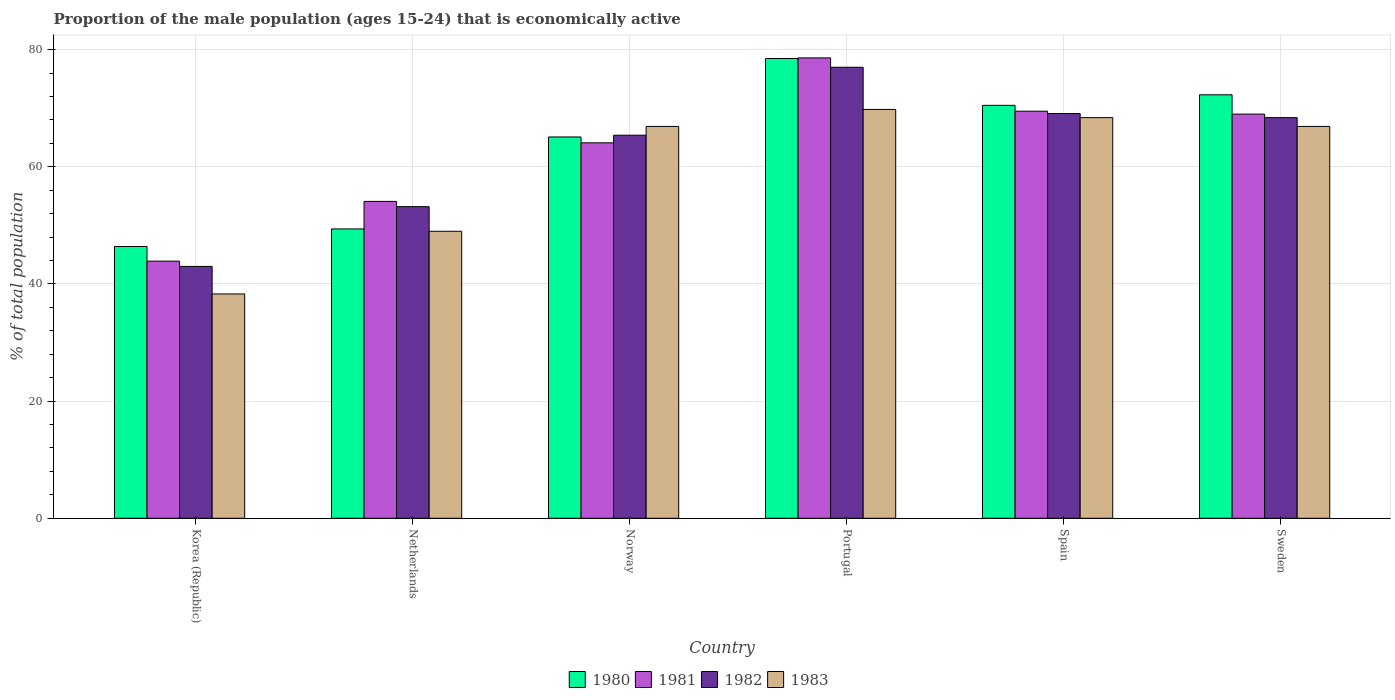How many groups of bars are there?
Provide a succinct answer. 6. Are the number of bars per tick equal to the number of legend labels?
Your response must be concise. Yes. In how many cases, is the number of bars for a given country not equal to the number of legend labels?
Give a very brief answer. 0. What is the proportion of the male population that is economically active in 1981 in Norway?
Your response must be concise. 64.1. Across all countries, what is the maximum proportion of the male population that is economically active in 1981?
Offer a terse response. 78.6. In which country was the proportion of the male population that is economically active in 1981 maximum?
Provide a short and direct response. Portugal. What is the total proportion of the male population that is economically active in 1982 in the graph?
Your answer should be very brief. 376.1. What is the difference between the proportion of the male population that is economically active in 1981 in Netherlands and that in Spain?
Offer a terse response. -15.4. What is the difference between the proportion of the male population that is economically active in 1980 in Sweden and the proportion of the male population that is economically active in 1982 in Spain?
Your answer should be compact. 3.2. What is the average proportion of the male population that is economically active in 1980 per country?
Your answer should be compact. 63.7. What is the difference between the proportion of the male population that is economically active of/in 1982 and proportion of the male population that is economically active of/in 1981 in Netherlands?
Keep it short and to the point. -0.9. In how many countries, is the proportion of the male population that is economically active in 1980 greater than 28 %?
Offer a very short reply. 6. What is the ratio of the proportion of the male population that is economically active in 1981 in Portugal to that in Sweden?
Offer a very short reply. 1.14. Is the proportion of the male population that is economically active in 1982 in Netherlands less than that in Spain?
Offer a terse response. Yes. What is the difference between the highest and the second highest proportion of the male population that is economically active in 1980?
Provide a succinct answer. 1.8. What is the difference between the highest and the lowest proportion of the male population that is economically active in 1980?
Ensure brevity in your answer.  32.1. In how many countries, is the proportion of the male population that is economically active in 1983 greater than the average proportion of the male population that is economically active in 1983 taken over all countries?
Your answer should be compact. 4. Is it the case that in every country, the sum of the proportion of the male population that is economically active in 1981 and proportion of the male population that is economically active in 1983 is greater than the sum of proportion of the male population that is economically active in 1980 and proportion of the male population that is economically active in 1982?
Your answer should be very brief. No. What does the 4th bar from the left in Norway represents?
Your answer should be compact. 1983. Is it the case that in every country, the sum of the proportion of the male population that is economically active in 1981 and proportion of the male population that is economically active in 1983 is greater than the proportion of the male population that is economically active in 1980?
Make the answer very short. Yes. Are all the bars in the graph horizontal?
Provide a short and direct response. No. What is the difference between two consecutive major ticks on the Y-axis?
Your answer should be compact. 20. Does the graph contain grids?
Your answer should be very brief. Yes. Where does the legend appear in the graph?
Your answer should be compact. Bottom center. How many legend labels are there?
Offer a terse response. 4. How are the legend labels stacked?
Make the answer very short. Horizontal. What is the title of the graph?
Ensure brevity in your answer.  Proportion of the male population (ages 15-24) that is economically active. What is the label or title of the X-axis?
Keep it short and to the point. Country. What is the label or title of the Y-axis?
Your answer should be very brief. % of total population. What is the % of total population of 1980 in Korea (Republic)?
Provide a succinct answer. 46.4. What is the % of total population of 1981 in Korea (Republic)?
Offer a terse response. 43.9. What is the % of total population in 1983 in Korea (Republic)?
Your answer should be compact. 38.3. What is the % of total population in 1980 in Netherlands?
Your response must be concise. 49.4. What is the % of total population of 1981 in Netherlands?
Provide a short and direct response. 54.1. What is the % of total population of 1982 in Netherlands?
Offer a terse response. 53.2. What is the % of total population in 1980 in Norway?
Your response must be concise. 65.1. What is the % of total population of 1981 in Norway?
Provide a short and direct response. 64.1. What is the % of total population in 1982 in Norway?
Offer a terse response. 65.4. What is the % of total population of 1983 in Norway?
Your answer should be compact. 66.9. What is the % of total population of 1980 in Portugal?
Provide a succinct answer. 78.5. What is the % of total population of 1981 in Portugal?
Provide a short and direct response. 78.6. What is the % of total population of 1982 in Portugal?
Ensure brevity in your answer.  77. What is the % of total population of 1983 in Portugal?
Provide a short and direct response. 69.8. What is the % of total population in 1980 in Spain?
Provide a succinct answer. 70.5. What is the % of total population in 1981 in Spain?
Ensure brevity in your answer.  69.5. What is the % of total population of 1982 in Spain?
Offer a terse response. 69.1. What is the % of total population of 1983 in Spain?
Give a very brief answer. 68.4. What is the % of total population of 1980 in Sweden?
Offer a very short reply. 72.3. What is the % of total population of 1981 in Sweden?
Offer a very short reply. 69. What is the % of total population of 1982 in Sweden?
Give a very brief answer. 68.4. What is the % of total population of 1983 in Sweden?
Your response must be concise. 66.9. Across all countries, what is the maximum % of total population in 1980?
Offer a terse response. 78.5. Across all countries, what is the maximum % of total population in 1981?
Provide a succinct answer. 78.6. Across all countries, what is the maximum % of total population of 1982?
Your answer should be very brief. 77. Across all countries, what is the maximum % of total population in 1983?
Make the answer very short. 69.8. Across all countries, what is the minimum % of total population of 1980?
Provide a succinct answer. 46.4. Across all countries, what is the minimum % of total population of 1981?
Your answer should be very brief. 43.9. Across all countries, what is the minimum % of total population in 1983?
Your answer should be very brief. 38.3. What is the total % of total population of 1980 in the graph?
Provide a succinct answer. 382.2. What is the total % of total population in 1981 in the graph?
Give a very brief answer. 379.2. What is the total % of total population in 1982 in the graph?
Ensure brevity in your answer.  376.1. What is the total % of total population in 1983 in the graph?
Offer a terse response. 359.3. What is the difference between the % of total population of 1981 in Korea (Republic) and that in Netherlands?
Provide a succinct answer. -10.2. What is the difference between the % of total population of 1982 in Korea (Republic) and that in Netherlands?
Keep it short and to the point. -10.2. What is the difference between the % of total population of 1983 in Korea (Republic) and that in Netherlands?
Keep it short and to the point. -10.7. What is the difference between the % of total population in 1980 in Korea (Republic) and that in Norway?
Offer a terse response. -18.7. What is the difference between the % of total population in 1981 in Korea (Republic) and that in Norway?
Give a very brief answer. -20.2. What is the difference between the % of total population of 1982 in Korea (Republic) and that in Norway?
Offer a terse response. -22.4. What is the difference between the % of total population of 1983 in Korea (Republic) and that in Norway?
Your answer should be very brief. -28.6. What is the difference between the % of total population in 1980 in Korea (Republic) and that in Portugal?
Your response must be concise. -32.1. What is the difference between the % of total population in 1981 in Korea (Republic) and that in Portugal?
Offer a very short reply. -34.7. What is the difference between the % of total population in 1982 in Korea (Republic) and that in Portugal?
Provide a succinct answer. -34. What is the difference between the % of total population in 1983 in Korea (Republic) and that in Portugal?
Offer a very short reply. -31.5. What is the difference between the % of total population of 1980 in Korea (Republic) and that in Spain?
Provide a short and direct response. -24.1. What is the difference between the % of total population in 1981 in Korea (Republic) and that in Spain?
Offer a terse response. -25.6. What is the difference between the % of total population in 1982 in Korea (Republic) and that in Spain?
Provide a succinct answer. -26.1. What is the difference between the % of total population in 1983 in Korea (Republic) and that in Spain?
Make the answer very short. -30.1. What is the difference between the % of total population of 1980 in Korea (Republic) and that in Sweden?
Provide a succinct answer. -25.9. What is the difference between the % of total population of 1981 in Korea (Republic) and that in Sweden?
Your answer should be very brief. -25.1. What is the difference between the % of total population in 1982 in Korea (Republic) and that in Sweden?
Offer a terse response. -25.4. What is the difference between the % of total population in 1983 in Korea (Republic) and that in Sweden?
Your response must be concise. -28.6. What is the difference between the % of total population in 1980 in Netherlands and that in Norway?
Give a very brief answer. -15.7. What is the difference between the % of total population of 1981 in Netherlands and that in Norway?
Your response must be concise. -10. What is the difference between the % of total population in 1983 in Netherlands and that in Norway?
Ensure brevity in your answer.  -17.9. What is the difference between the % of total population in 1980 in Netherlands and that in Portugal?
Ensure brevity in your answer.  -29.1. What is the difference between the % of total population of 1981 in Netherlands and that in Portugal?
Keep it short and to the point. -24.5. What is the difference between the % of total population of 1982 in Netherlands and that in Portugal?
Make the answer very short. -23.8. What is the difference between the % of total population in 1983 in Netherlands and that in Portugal?
Offer a terse response. -20.8. What is the difference between the % of total population of 1980 in Netherlands and that in Spain?
Provide a succinct answer. -21.1. What is the difference between the % of total population of 1981 in Netherlands and that in Spain?
Give a very brief answer. -15.4. What is the difference between the % of total population in 1982 in Netherlands and that in Spain?
Your answer should be compact. -15.9. What is the difference between the % of total population in 1983 in Netherlands and that in Spain?
Give a very brief answer. -19.4. What is the difference between the % of total population in 1980 in Netherlands and that in Sweden?
Give a very brief answer. -22.9. What is the difference between the % of total population in 1981 in Netherlands and that in Sweden?
Offer a terse response. -14.9. What is the difference between the % of total population of 1982 in Netherlands and that in Sweden?
Your answer should be very brief. -15.2. What is the difference between the % of total population in 1983 in Netherlands and that in Sweden?
Your answer should be compact. -17.9. What is the difference between the % of total population in 1980 in Norway and that in Portugal?
Give a very brief answer. -13.4. What is the difference between the % of total population in 1980 in Norway and that in Spain?
Your answer should be very brief. -5.4. What is the difference between the % of total population in 1981 in Norway and that in Spain?
Keep it short and to the point. -5.4. What is the difference between the % of total population of 1983 in Norway and that in Spain?
Offer a very short reply. -1.5. What is the difference between the % of total population in 1982 in Norway and that in Sweden?
Offer a terse response. -3. What is the difference between the % of total population of 1983 in Norway and that in Sweden?
Make the answer very short. 0. What is the difference between the % of total population of 1982 in Portugal and that in Spain?
Give a very brief answer. 7.9. What is the difference between the % of total population of 1980 in Portugal and that in Sweden?
Your response must be concise. 6.2. What is the difference between the % of total population in 1981 in Spain and that in Sweden?
Keep it short and to the point. 0.5. What is the difference between the % of total population in 1982 in Spain and that in Sweden?
Your answer should be very brief. 0.7. What is the difference between the % of total population in 1983 in Spain and that in Sweden?
Provide a short and direct response. 1.5. What is the difference between the % of total population in 1980 in Korea (Republic) and the % of total population in 1981 in Netherlands?
Offer a very short reply. -7.7. What is the difference between the % of total population in 1980 in Korea (Republic) and the % of total population in 1982 in Netherlands?
Your answer should be compact. -6.8. What is the difference between the % of total population of 1980 in Korea (Republic) and the % of total population of 1983 in Netherlands?
Make the answer very short. -2.6. What is the difference between the % of total population of 1982 in Korea (Republic) and the % of total population of 1983 in Netherlands?
Provide a short and direct response. -6. What is the difference between the % of total population in 1980 in Korea (Republic) and the % of total population in 1981 in Norway?
Provide a succinct answer. -17.7. What is the difference between the % of total population of 1980 in Korea (Republic) and the % of total population of 1982 in Norway?
Provide a short and direct response. -19. What is the difference between the % of total population of 1980 in Korea (Republic) and the % of total population of 1983 in Norway?
Offer a very short reply. -20.5. What is the difference between the % of total population of 1981 in Korea (Republic) and the % of total population of 1982 in Norway?
Your response must be concise. -21.5. What is the difference between the % of total population of 1981 in Korea (Republic) and the % of total population of 1983 in Norway?
Keep it short and to the point. -23. What is the difference between the % of total population in 1982 in Korea (Republic) and the % of total population in 1983 in Norway?
Provide a short and direct response. -23.9. What is the difference between the % of total population in 1980 in Korea (Republic) and the % of total population in 1981 in Portugal?
Your response must be concise. -32.2. What is the difference between the % of total population in 1980 in Korea (Republic) and the % of total population in 1982 in Portugal?
Give a very brief answer. -30.6. What is the difference between the % of total population in 1980 in Korea (Republic) and the % of total population in 1983 in Portugal?
Make the answer very short. -23.4. What is the difference between the % of total population in 1981 in Korea (Republic) and the % of total population in 1982 in Portugal?
Make the answer very short. -33.1. What is the difference between the % of total population in 1981 in Korea (Republic) and the % of total population in 1983 in Portugal?
Give a very brief answer. -25.9. What is the difference between the % of total population of 1982 in Korea (Republic) and the % of total population of 1983 in Portugal?
Give a very brief answer. -26.8. What is the difference between the % of total population in 1980 in Korea (Republic) and the % of total population in 1981 in Spain?
Offer a terse response. -23.1. What is the difference between the % of total population in 1980 in Korea (Republic) and the % of total population in 1982 in Spain?
Your answer should be very brief. -22.7. What is the difference between the % of total population of 1981 in Korea (Republic) and the % of total population of 1982 in Spain?
Your response must be concise. -25.2. What is the difference between the % of total population in 1981 in Korea (Republic) and the % of total population in 1983 in Spain?
Ensure brevity in your answer.  -24.5. What is the difference between the % of total population in 1982 in Korea (Republic) and the % of total population in 1983 in Spain?
Your response must be concise. -25.4. What is the difference between the % of total population of 1980 in Korea (Republic) and the % of total population of 1981 in Sweden?
Offer a terse response. -22.6. What is the difference between the % of total population of 1980 in Korea (Republic) and the % of total population of 1983 in Sweden?
Keep it short and to the point. -20.5. What is the difference between the % of total population in 1981 in Korea (Republic) and the % of total population in 1982 in Sweden?
Keep it short and to the point. -24.5. What is the difference between the % of total population in 1982 in Korea (Republic) and the % of total population in 1983 in Sweden?
Keep it short and to the point. -23.9. What is the difference between the % of total population in 1980 in Netherlands and the % of total population in 1981 in Norway?
Your answer should be compact. -14.7. What is the difference between the % of total population in 1980 in Netherlands and the % of total population in 1982 in Norway?
Your answer should be very brief. -16. What is the difference between the % of total population of 1980 in Netherlands and the % of total population of 1983 in Norway?
Your answer should be compact. -17.5. What is the difference between the % of total population in 1981 in Netherlands and the % of total population in 1982 in Norway?
Ensure brevity in your answer.  -11.3. What is the difference between the % of total population in 1982 in Netherlands and the % of total population in 1983 in Norway?
Your answer should be very brief. -13.7. What is the difference between the % of total population of 1980 in Netherlands and the % of total population of 1981 in Portugal?
Your response must be concise. -29.2. What is the difference between the % of total population in 1980 in Netherlands and the % of total population in 1982 in Portugal?
Provide a succinct answer. -27.6. What is the difference between the % of total population in 1980 in Netherlands and the % of total population in 1983 in Portugal?
Keep it short and to the point. -20.4. What is the difference between the % of total population in 1981 in Netherlands and the % of total population in 1982 in Portugal?
Keep it short and to the point. -22.9. What is the difference between the % of total population of 1981 in Netherlands and the % of total population of 1983 in Portugal?
Ensure brevity in your answer.  -15.7. What is the difference between the % of total population of 1982 in Netherlands and the % of total population of 1983 in Portugal?
Provide a succinct answer. -16.6. What is the difference between the % of total population of 1980 in Netherlands and the % of total population of 1981 in Spain?
Keep it short and to the point. -20.1. What is the difference between the % of total population of 1980 in Netherlands and the % of total population of 1982 in Spain?
Offer a terse response. -19.7. What is the difference between the % of total population of 1980 in Netherlands and the % of total population of 1983 in Spain?
Keep it short and to the point. -19. What is the difference between the % of total population in 1981 in Netherlands and the % of total population in 1982 in Spain?
Your answer should be compact. -15. What is the difference between the % of total population of 1981 in Netherlands and the % of total population of 1983 in Spain?
Offer a terse response. -14.3. What is the difference between the % of total population in 1982 in Netherlands and the % of total population in 1983 in Spain?
Offer a very short reply. -15.2. What is the difference between the % of total population in 1980 in Netherlands and the % of total population in 1981 in Sweden?
Give a very brief answer. -19.6. What is the difference between the % of total population in 1980 in Netherlands and the % of total population in 1982 in Sweden?
Ensure brevity in your answer.  -19. What is the difference between the % of total population of 1980 in Netherlands and the % of total population of 1983 in Sweden?
Provide a short and direct response. -17.5. What is the difference between the % of total population of 1981 in Netherlands and the % of total population of 1982 in Sweden?
Make the answer very short. -14.3. What is the difference between the % of total population of 1982 in Netherlands and the % of total population of 1983 in Sweden?
Your answer should be very brief. -13.7. What is the difference between the % of total population in 1981 in Norway and the % of total population in 1983 in Portugal?
Ensure brevity in your answer.  -5.7. What is the difference between the % of total population of 1980 in Norway and the % of total population of 1982 in Spain?
Your answer should be very brief. -4. What is the difference between the % of total population in 1981 in Norway and the % of total population in 1982 in Spain?
Ensure brevity in your answer.  -5. What is the difference between the % of total population in 1981 in Norway and the % of total population in 1983 in Spain?
Provide a succinct answer. -4.3. What is the difference between the % of total population in 1980 in Norway and the % of total population in 1982 in Sweden?
Your answer should be compact. -3.3. What is the difference between the % of total population of 1981 in Norway and the % of total population of 1982 in Sweden?
Your answer should be compact. -4.3. What is the difference between the % of total population of 1980 in Portugal and the % of total population of 1981 in Spain?
Keep it short and to the point. 9. What is the difference between the % of total population in 1980 in Portugal and the % of total population in 1983 in Spain?
Keep it short and to the point. 10.1. What is the difference between the % of total population in 1981 in Portugal and the % of total population in 1983 in Spain?
Offer a terse response. 10.2. What is the difference between the % of total population of 1980 in Portugal and the % of total population of 1981 in Sweden?
Make the answer very short. 9.5. What is the difference between the % of total population in 1980 in Portugal and the % of total population in 1982 in Sweden?
Ensure brevity in your answer.  10.1. What is the difference between the % of total population of 1981 in Portugal and the % of total population of 1983 in Sweden?
Provide a succinct answer. 11.7. What is the difference between the % of total population of 1981 in Spain and the % of total population of 1983 in Sweden?
Your answer should be compact. 2.6. What is the difference between the % of total population in 1982 in Spain and the % of total population in 1983 in Sweden?
Your answer should be compact. 2.2. What is the average % of total population of 1980 per country?
Your answer should be compact. 63.7. What is the average % of total population in 1981 per country?
Make the answer very short. 63.2. What is the average % of total population of 1982 per country?
Ensure brevity in your answer.  62.68. What is the average % of total population in 1983 per country?
Make the answer very short. 59.88. What is the difference between the % of total population of 1980 and % of total population of 1981 in Korea (Republic)?
Give a very brief answer. 2.5. What is the difference between the % of total population in 1980 and % of total population in 1982 in Korea (Republic)?
Your answer should be compact. 3.4. What is the difference between the % of total population of 1981 and % of total population of 1983 in Korea (Republic)?
Keep it short and to the point. 5.6. What is the difference between the % of total population of 1982 and % of total population of 1983 in Korea (Republic)?
Your response must be concise. 4.7. What is the difference between the % of total population in 1980 and % of total population in 1981 in Netherlands?
Keep it short and to the point. -4.7. What is the difference between the % of total population in 1980 and % of total population in 1983 in Netherlands?
Make the answer very short. 0.4. What is the difference between the % of total population in 1981 and % of total population in 1983 in Netherlands?
Keep it short and to the point. 5.1. What is the difference between the % of total population in 1982 and % of total population in 1983 in Netherlands?
Provide a short and direct response. 4.2. What is the difference between the % of total population of 1980 and % of total population of 1983 in Norway?
Ensure brevity in your answer.  -1.8. What is the difference between the % of total population of 1981 and % of total population of 1982 in Norway?
Ensure brevity in your answer.  -1.3. What is the difference between the % of total population of 1981 and % of total population of 1983 in Norway?
Your answer should be compact. -2.8. What is the difference between the % of total population of 1982 and % of total population of 1983 in Norway?
Provide a succinct answer. -1.5. What is the difference between the % of total population in 1980 and % of total population in 1981 in Portugal?
Ensure brevity in your answer.  -0.1. What is the difference between the % of total population in 1981 and % of total population in 1982 in Portugal?
Provide a succinct answer. 1.6. What is the difference between the % of total population in 1981 and % of total population in 1983 in Portugal?
Provide a short and direct response. 8.8. What is the difference between the % of total population of 1982 and % of total population of 1983 in Portugal?
Your response must be concise. 7.2. What is the difference between the % of total population of 1980 and % of total population of 1983 in Spain?
Provide a succinct answer. 2.1. What is the difference between the % of total population in 1982 and % of total population in 1983 in Spain?
Your response must be concise. 0.7. What is the difference between the % of total population in 1980 and % of total population in 1981 in Sweden?
Provide a succinct answer. 3.3. What is the difference between the % of total population in 1980 and % of total population in 1982 in Sweden?
Offer a terse response. 3.9. What is the difference between the % of total population in 1982 and % of total population in 1983 in Sweden?
Your answer should be compact. 1.5. What is the ratio of the % of total population of 1980 in Korea (Republic) to that in Netherlands?
Give a very brief answer. 0.94. What is the ratio of the % of total population in 1981 in Korea (Republic) to that in Netherlands?
Give a very brief answer. 0.81. What is the ratio of the % of total population in 1982 in Korea (Republic) to that in Netherlands?
Make the answer very short. 0.81. What is the ratio of the % of total population in 1983 in Korea (Republic) to that in Netherlands?
Provide a short and direct response. 0.78. What is the ratio of the % of total population in 1980 in Korea (Republic) to that in Norway?
Provide a succinct answer. 0.71. What is the ratio of the % of total population in 1981 in Korea (Republic) to that in Norway?
Make the answer very short. 0.68. What is the ratio of the % of total population of 1982 in Korea (Republic) to that in Norway?
Provide a short and direct response. 0.66. What is the ratio of the % of total population in 1983 in Korea (Republic) to that in Norway?
Ensure brevity in your answer.  0.57. What is the ratio of the % of total population in 1980 in Korea (Republic) to that in Portugal?
Your answer should be compact. 0.59. What is the ratio of the % of total population of 1981 in Korea (Republic) to that in Portugal?
Your answer should be very brief. 0.56. What is the ratio of the % of total population in 1982 in Korea (Republic) to that in Portugal?
Your answer should be very brief. 0.56. What is the ratio of the % of total population of 1983 in Korea (Republic) to that in Portugal?
Offer a very short reply. 0.55. What is the ratio of the % of total population of 1980 in Korea (Republic) to that in Spain?
Ensure brevity in your answer.  0.66. What is the ratio of the % of total population of 1981 in Korea (Republic) to that in Spain?
Ensure brevity in your answer.  0.63. What is the ratio of the % of total population in 1982 in Korea (Republic) to that in Spain?
Give a very brief answer. 0.62. What is the ratio of the % of total population in 1983 in Korea (Republic) to that in Spain?
Ensure brevity in your answer.  0.56. What is the ratio of the % of total population of 1980 in Korea (Republic) to that in Sweden?
Offer a terse response. 0.64. What is the ratio of the % of total population of 1981 in Korea (Republic) to that in Sweden?
Ensure brevity in your answer.  0.64. What is the ratio of the % of total population of 1982 in Korea (Republic) to that in Sweden?
Your response must be concise. 0.63. What is the ratio of the % of total population in 1983 in Korea (Republic) to that in Sweden?
Your response must be concise. 0.57. What is the ratio of the % of total population of 1980 in Netherlands to that in Norway?
Your answer should be very brief. 0.76. What is the ratio of the % of total population in 1981 in Netherlands to that in Norway?
Offer a very short reply. 0.84. What is the ratio of the % of total population of 1982 in Netherlands to that in Norway?
Ensure brevity in your answer.  0.81. What is the ratio of the % of total population in 1983 in Netherlands to that in Norway?
Ensure brevity in your answer.  0.73. What is the ratio of the % of total population in 1980 in Netherlands to that in Portugal?
Your answer should be compact. 0.63. What is the ratio of the % of total population in 1981 in Netherlands to that in Portugal?
Give a very brief answer. 0.69. What is the ratio of the % of total population of 1982 in Netherlands to that in Portugal?
Give a very brief answer. 0.69. What is the ratio of the % of total population in 1983 in Netherlands to that in Portugal?
Provide a succinct answer. 0.7. What is the ratio of the % of total population in 1980 in Netherlands to that in Spain?
Your response must be concise. 0.7. What is the ratio of the % of total population of 1981 in Netherlands to that in Spain?
Make the answer very short. 0.78. What is the ratio of the % of total population of 1982 in Netherlands to that in Spain?
Offer a terse response. 0.77. What is the ratio of the % of total population in 1983 in Netherlands to that in Spain?
Your response must be concise. 0.72. What is the ratio of the % of total population of 1980 in Netherlands to that in Sweden?
Provide a succinct answer. 0.68. What is the ratio of the % of total population of 1981 in Netherlands to that in Sweden?
Provide a short and direct response. 0.78. What is the ratio of the % of total population of 1983 in Netherlands to that in Sweden?
Ensure brevity in your answer.  0.73. What is the ratio of the % of total population in 1980 in Norway to that in Portugal?
Your response must be concise. 0.83. What is the ratio of the % of total population in 1981 in Norway to that in Portugal?
Your answer should be compact. 0.82. What is the ratio of the % of total population of 1982 in Norway to that in Portugal?
Your answer should be compact. 0.85. What is the ratio of the % of total population of 1983 in Norway to that in Portugal?
Offer a very short reply. 0.96. What is the ratio of the % of total population in 1980 in Norway to that in Spain?
Keep it short and to the point. 0.92. What is the ratio of the % of total population in 1981 in Norway to that in Spain?
Ensure brevity in your answer.  0.92. What is the ratio of the % of total population in 1982 in Norway to that in Spain?
Offer a very short reply. 0.95. What is the ratio of the % of total population in 1983 in Norway to that in Spain?
Keep it short and to the point. 0.98. What is the ratio of the % of total population in 1980 in Norway to that in Sweden?
Make the answer very short. 0.9. What is the ratio of the % of total population in 1981 in Norway to that in Sweden?
Offer a very short reply. 0.93. What is the ratio of the % of total population of 1982 in Norway to that in Sweden?
Make the answer very short. 0.96. What is the ratio of the % of total population of 1983 in Norway to that in Sweden?
Your answer should be compact. 1. What is the ratio of the % of total population of 1980 in Portugal to that in Spain?
Offer a terse response. 1.11. What is the ratio of the % of total population of 1981 in Portugal to that in Spain?
Provide a short and direct response. 1.13. What is the ratio of the % of total population of 1982 in Portugal to that in Spain?
Ensure brevity in your answer.  1.11. What is the ratio of the % of total population of 1983 in Portugal to that in Spain?
Your answer should be very brief. 1.02. What is the ratio of the % of total population in 1980 in Portugal to that in Sweden?
Offer a very short reply. 1.09. What is the ratio of the % of total population of 1981 in Portugal to that in Sweden?
Make the answer very short. 1.14. What is the ratio of the % of total population of 1982 in Portugal to that in Sweden?
Keep it short and to the point. 1.13. What is the ratio of the % of total population in 1983 in Portugal to that in Sweden?
Your answer should be very brief. 1.04. What is the ratio of the % of total population of 1980 in Spain to that in Sweden?
Your response must be concise. 0.98. What is the ratio of the % of total population in 1981 in Spain to that in Sweden?
Ensure brevity in your answer.  1.01. What is the ratio of the % of total population in 1982 in Spain to that in Sweden?
Provide a succinct answer. 1.01. What is the ratio of the % of total population of 1983 in Spain to that in Sweden?
Make the answer very short. 1.02. What is the difference between the highest and the second highest % of total population in 1980?
Your answer should be compact. 6.2. What is the difference between the highest and the second highest % of total population in 1983?
Offer a terse response. 1.4. What is the difference between the highest and the lowest % of total population of 1980?
Keep it short and to the point. 32.1. What is the difference between the highest and the lowest % of total population of 1981?
Give a very brief answer. 34.7. What is the difference between the highest and the lowest % of total population of 1983?
Keep it short and to the point. 31.5. 